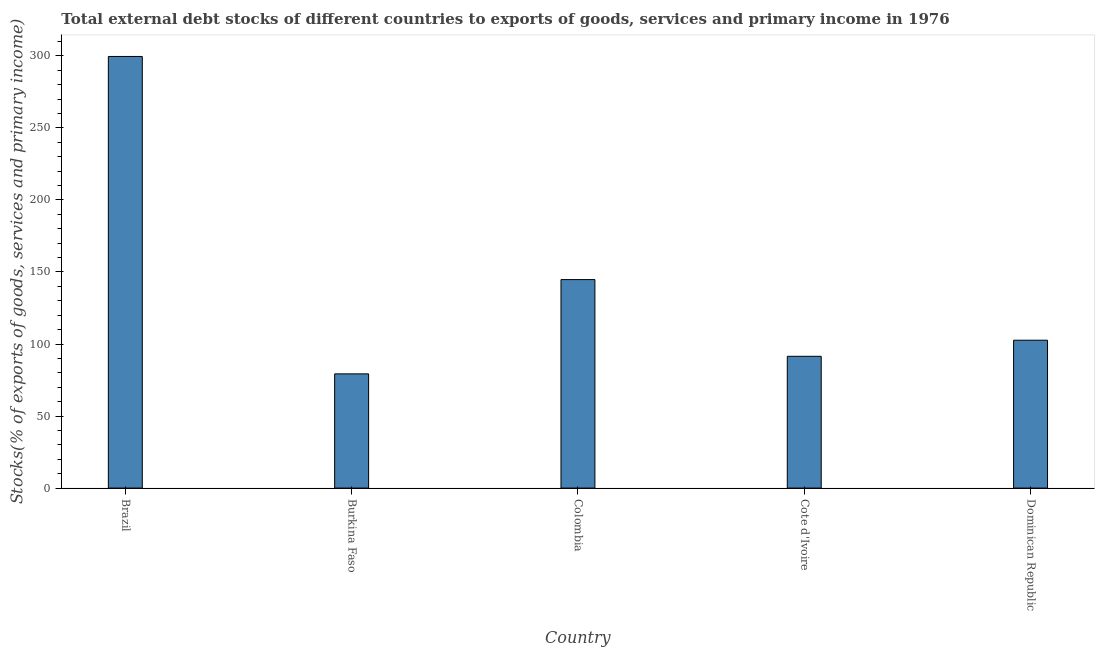What is the title of the graph?
Give a very brief answer. Total external debt stocks of different countries to exports of goods, services and primary income in 1976. What is the label or title of the X-axis?
Give a very brief answer. Country. What is the label or title of the Y-axis?
Offer a terse response. Stocks(% of exports of goods, services and primary income). What is the external debt stocks in Colombia?
Your response must be concise. 144.7. Across all countries, what is the maximum external debt stocks?
Provide a short and direct response. 299.56. Across all countries, what is the minimum external debt stocks?
Your answer should be compact. 79.27. In which country was the external debt stocks minimum?
Your answer should be very brief. Burkina Faso. What is the sum of the external debt stocks?
Your answer should be very brief. 717.63. What is the difference between the external debt stocks in Cote d'Ivoire and Dominican Republic?
Give a very brief answer. -11.16. What is the average external debt stocks per country?
Your answer should be compact. 143.53. What is the median external debt stocks?
Offer a terse response. 102.63. In how many countries, is the external debt stocks greater than 90 %?
Your response must be concise. 4. What is the ratio of the external debt stocks in Colombia to that in Cote d'Ivoire?
Offer a terse response. 1.58. Is the external debt stocks in Brazil less than that in Colombia?
Keep it short and to the point. No. What is the difference between the highest and the second highest external debt stocks?
Offer a very short reply. 154.86. What is the difference between the highest and the lowest external debt stocks?
Offer a very short reply. 220.29. How many countries are there in the graph?
Your response must be concise. 5. What is the difference between two consecutive major ticks on the Y-axis?
Give a very brief answer. 50. Are the values on the major ticks of Y-axis written in scientific E-notation?
Offer a very short reply. No. What is the Stocks(% of exports of goods, services and primary income) of Brazil?
Give a very brief answer. 299.56. What is the Stocks(% of exports of goods, services and primary income) of Burkina Faso?
Give a very brief answer. 79.27. What is the Stocks(% of exports of goods, services and primary income) of Colombia?
Offer a terse response. 144.7. What is the Stocks(% of exports of goods, services and primary income) in Cote d'Ivoire?
Offer a very short reply. 91.47. What is the Stocks(% of exports of goods, services and primary income) in Dominican Republic?
Your answer should be compact. 102.63. What is the difference between the Stocks(% of exports of goods, services and primary income) in Brazil and Burkina Faso?
Your answer should be compact. 220.29. What is the difference between the Stocks(% of exports of goods, services and primary income) in Brazil and Colombia?
Make the answer very short. 154.86. What is the difference between the Stocks(% of exports of goods, services and primary income) in Brazil and Cote d'Ivoire?
Your answer should be compact. 208.09. What is the difference between the Stocks(% of exports of goods, services and primary income) in Brazil and Dominican Republic?
Your answer should be compact. 196.93. What is the difference between the Stocks(% of exports of goods, services and primary income) in Burkina Faso and Colombia?
Your answer should be very brief. -65.43. What is the difference between the Stocks(% of exports of goods, services and primary income) in Burkina Faso and Cote d'Ivoire?
Ensure brevity in your answer.  -12.19. What is the difference between the Stocks(% of exports of goods, services and primary income) in Burkina Faso and Dominican Republic?
Keep it short and to the point. -23.36. What is the difference between the Stocks(% of exports of goods, services and primary income) in Colombia and Cote d'Ivoire?
Ensure brevity in your answer.  53.24. What is the difference between the Stocks(% of exports of goods, services and primary income) in Colombia and Dominican Republic?
Provide a succinct answer. 42.07. What is the difference between the Stocks(% of exports of goods, services and primary income) in Cote d'Ivoire and Dominican Republic?
Offer a terse response. -11.16. What is the ratio of the Stocks(% of exports of goods, services and primary income) in Brazil to that in Burkina Faso?
Your answer should be very brief. 3.78. What is the ratio of the Stocks(% of exports of goods, services and primary income) in Brazil to that in Colombia?
Your response must be concise. 2.07. What is the ratio of the Stocks(% of exports of goods, services and primary income) in Brazil to that in Cote d'Ivoire?
Offer a terse response. 3.27. What is the ratio of the Stocks(% of exports of goods, services and primary income) in Brazil to that in Dominican Republic?
Provide a succinct answer. 2.92. What is the ratio of the Stocks(% of exports of goods, services and primary income) in Burkina Faso to that in Colombia?
Offer a terse response. 0.55. What is the ratio of the Stocks(% of exports of goods, services and primary income) in Burkina Faso to that in Cote d'Ivoire?
Your response must be concise. 0.87. What is the ratio of the Stocks(% of exports of goods, services and primary income) in Burkina Faso to that in Dominican Republic?
Ensure brevity in your answer.  0.77. What is the ratio of the Stocks(% of exports of goods, services and primary income) in Colombia to that in Cote d'Ivoire?
Your response must be concise. 1.58. What is the ratio of the Stocks(% of exports of goods, services and primary income) in Colombia to that in Dominican Republic?
Offer a very short reply. 1.41. What is the ratio of the Stocks(% of exports of goods, services and primary income) in Cote d'Ivoire to that in Dominican Republic?
Your answer should be compact. 0.89. 